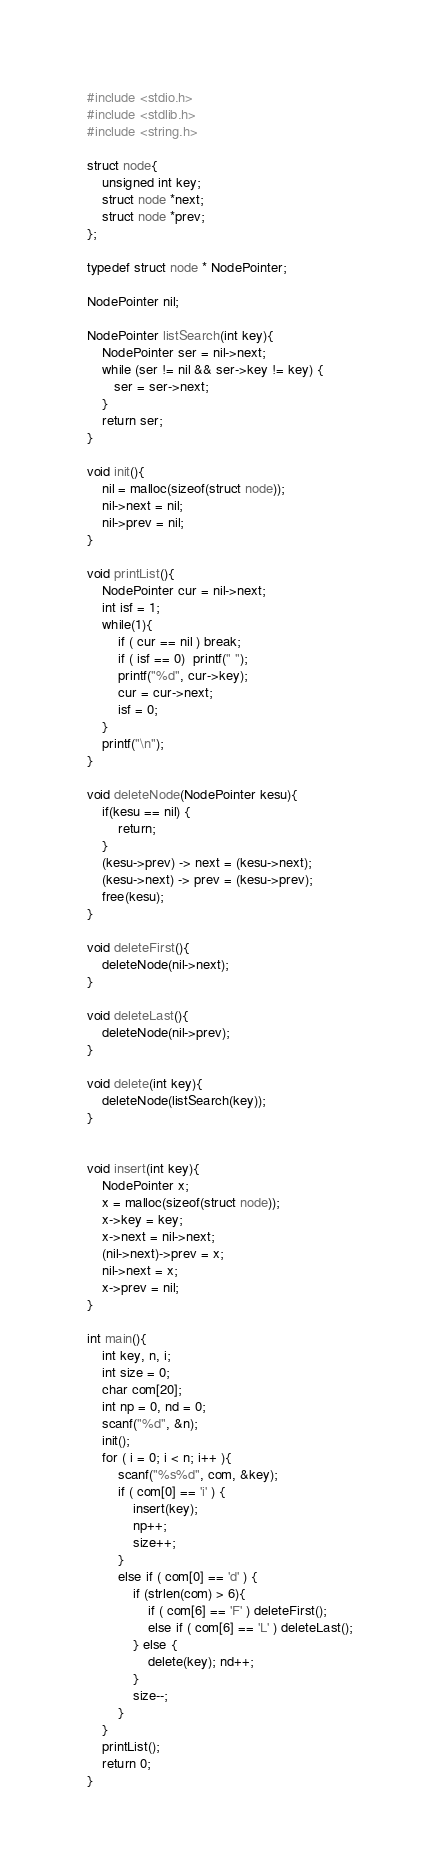<code> <loc_0><loc_0><loc_500><loc_500><_C_>#include <stdio.h>
#include <stdlib.h>
#include <string.h>

struct node{
    unsigned int key;
    struct node *next;
    struct node *prev;
};

typedef struct node * NodePointer;

NodePointer nil;

NodePointer listSearch(int key){
    NodePointer ser = nil->next;
    while (ser != nil && ser->key != key) {
       ser = ser->next;
    }
    return ser;
}

void init(){
    nil = malloc(sizeof(struct node));
    nil->next = nil;
    nil->prev = nil;
}

void printList(){
    NodePointer cur = nil->next;
    int isf = 1;
    while(1){
        if ( cur == nil ) break;
        if ( isf == 0)  printf(" ");
        printf("%d", cur->key);
        cur = cur->next;
        isf = 0;
    }
    printf("\n");
}

void deleteNode(NodePointer kesu){
    if(kesu == nil) {
        return;
    }
    (kesu->prev) -> next = (kesu->next);
    (kesu->next) -> prev = (kesu->prev);
    free(kesu);
}

void deleteFirst(){
    deleteNode(nil->next);
}

void deleteLast(){
    deleteNode(nil->prev);
}

void delete(int key){
    deleteNode(listSearch(key));
}


void insert(int key){
    NodePointer x;
    x = malloc(sizeof(struct node));
    x->key = key;
    x->next = nil->next;
    (nil->next)->prev = x;
    nil->next = x;
    x->prev = nil;
}

int main(){
    int key, n, i;
    int size = 0;
    char com[20];
    int np = 0, nd = 0;
    scanf("%d", &n);
    init();
    for ( i = 0; i < n; i++ ){
        scanf("%s%d", com, &key);
        if ( com[0] == 'i' ) {
            insert(key);
            np++;
            size++;
        }
        else if ( com[0] == 'd' ) {
            if (strlen(com) > 6){
                if ( com[6] == 'F' ) deleteFirst();
                else if ( com[6] == 'L' ) deleteLast();
            } else {
                delete(key); nd++;
            }
            size--;
        }
    }
    printList();
    return 0;
}
</code> 